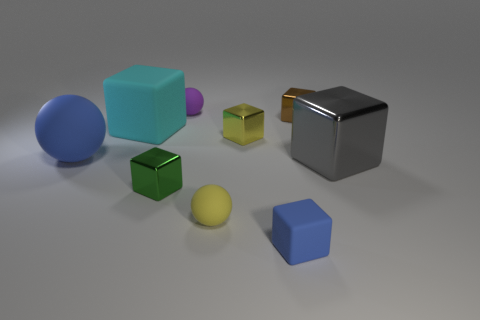The small brown object behind the large block in front of the rubber block that is behind the large gray metallic object is made of what material?
Provide a succinct answer. Metal. What number of other things are the same size as the gray object?
Your answer should be very brief. 2. Does the small matte block have the same color as the large rubber sphere?
Offer a terse response. Yes. What number of large cyan rubber blocks are behind the blue rubber block in front of the small yellow thing that is in front of the small green metallic object?
Provide a short and direct response. 1. What is the material of the big thing right of the tiny yellow thing in front of the big gray block?
Ensure brevity in your answer.  Metal. Are there any other small rubber objects that have the same shape as the yellow matte object?
Your answer should be very brief. Yes. There is a matte block that is the same size as the purple rubber sphere; what color is it?
Ensure brevity in your answer.  Blue. How many things are metallic things to the right of the small brown shiny cube or rubber balls on the left side of the purple object?
Provide a succinct answer. 2. How many things are either small yellow matte spheres or small purple matte balls?
Your response must be concise. 2. How big is the rubber thing that is behind the large matte ball and to the left of the purple matte thing?
Make the answer very short. Large. 